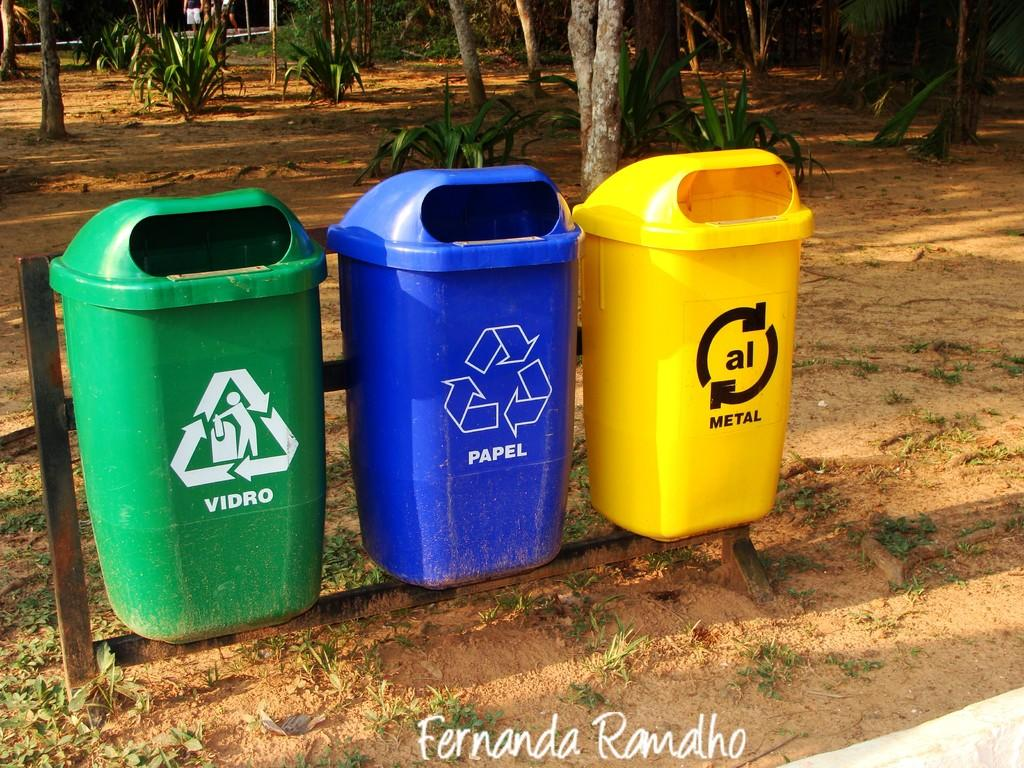Provide a one-sentence caption for the provided image. three recycle garbage cans that are Green, Blue, and Yellow, and say Vidro, Papel, and Metal. 